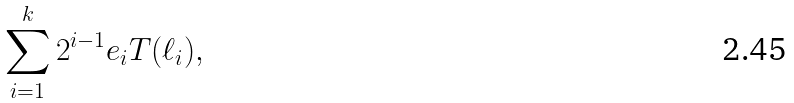<formula> <loc_0><loc_0><loc_500><loc_500>\sum _ { i = 1 } ^ { k } 2 ^ { i - 1 } e _ { i } T ( \ell _ { i } ) ,</formula> 